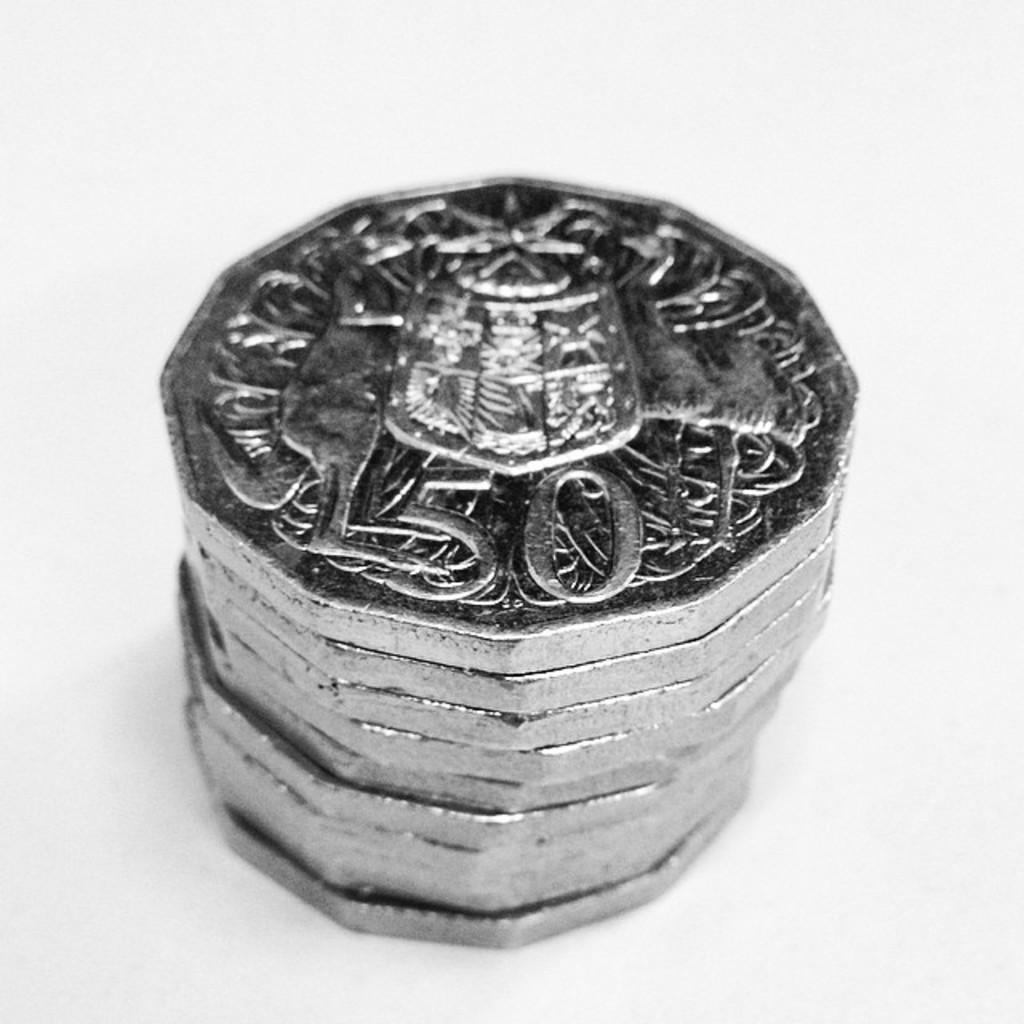<image>
Share a concise interpretation of the image provided. A stack of silver coins with a denomination of 50. 